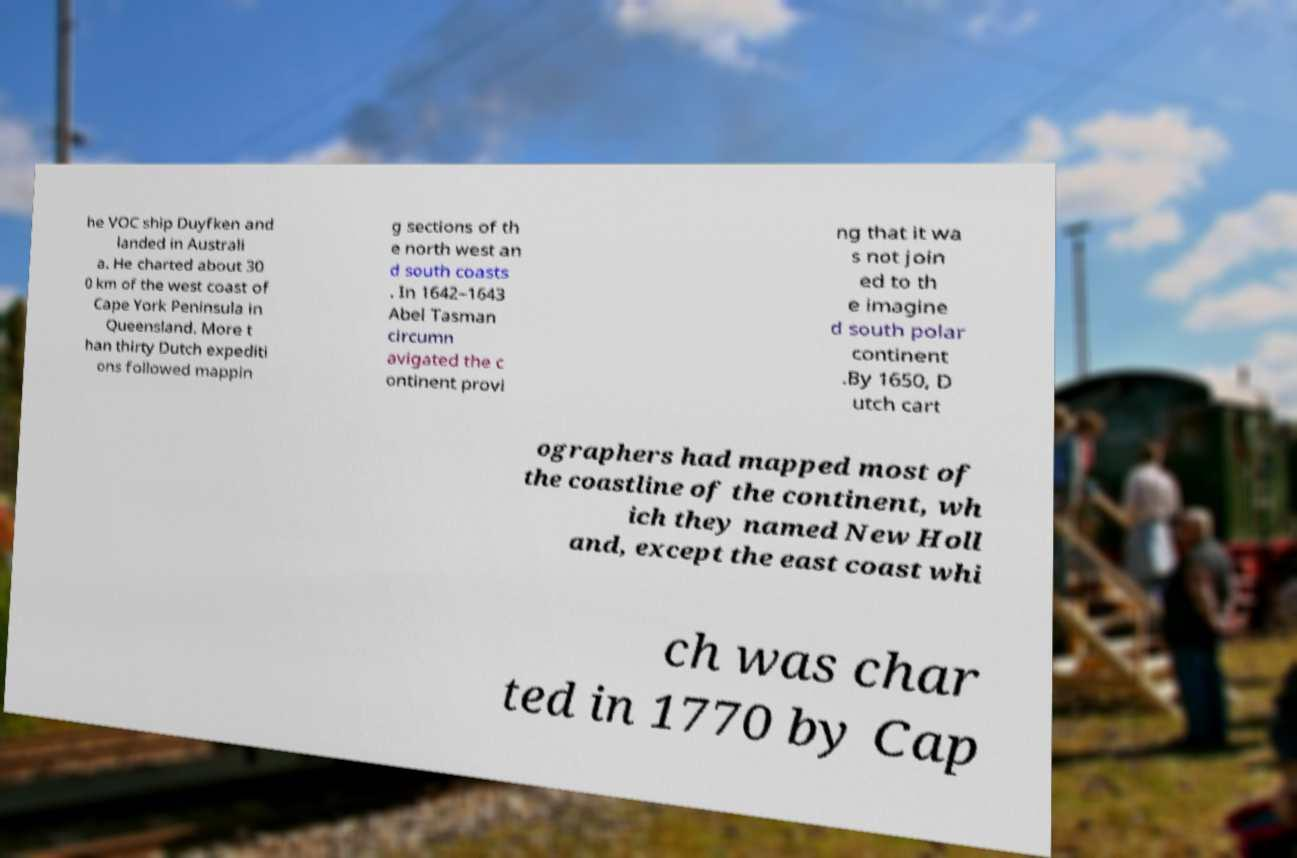Can you read and provide the text displayed in the image?This photo seems to have some interesting text. Can you extract and type it out for me? he VOC ship Duyfken and landed in Australi a. He charted about 30 0 km of the west coast of Cape York Peninsula in Queensland. More t han thirty Dutch expediti ons followed mappin g sections of th e north west an d south coasts . In 1642–1643 Abel Tasman circumn avigated the c ontinent provi ng that it wa s not join ed to th e imagine d south polar continent .By 1650, D utch cart ographers had mapped most of the coastline of the continent, wh ich they named New Holl and, except the east coast whi ch was char ted in 1770 by Cap 